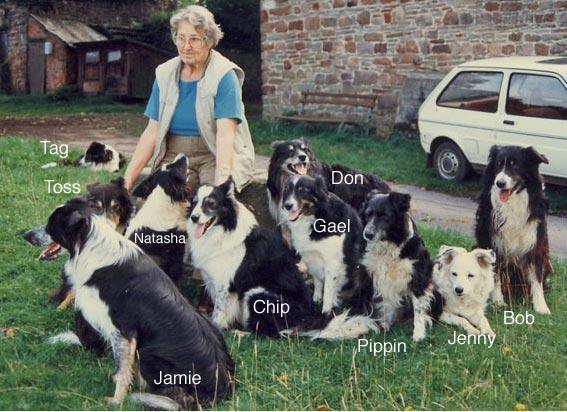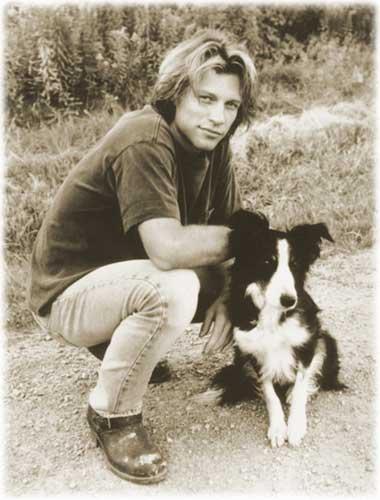The first image is the image on the left, the second image is the image on the right. For the images displayed, is the sentence "An image shows a long-haired man in jeans crouching behind a black-and-white dog." factually correct? Answer yes or no. Yes. The first image is the image on the left, the second image is the image on the right. For the images shown, is this caption "The right image contains only one human and one dog." true? Answer yes or no. Yes. 